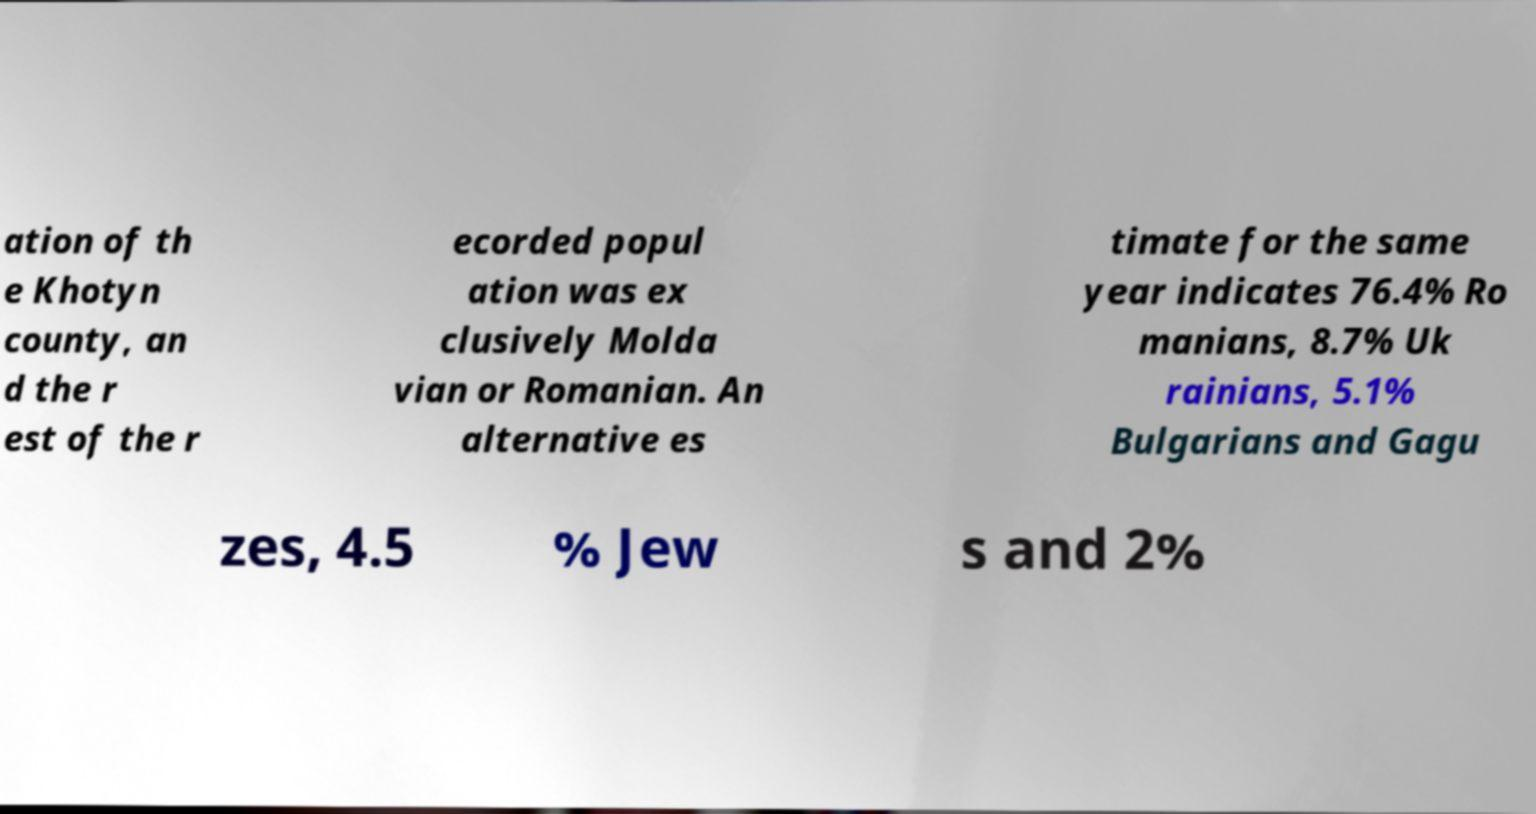Please identify and transcribe the text found in this image. ation of th e Khotyn county, an d the r est of the r ecorded popul ation was ex clusively Molda vian or Romanian. An alternative es timate for the same year indicates 76.4% Ro manians, 8.7% Uk rainians, 5.1% Bulgarians and Gagu zes, 4.5 % Jew s and 2% 